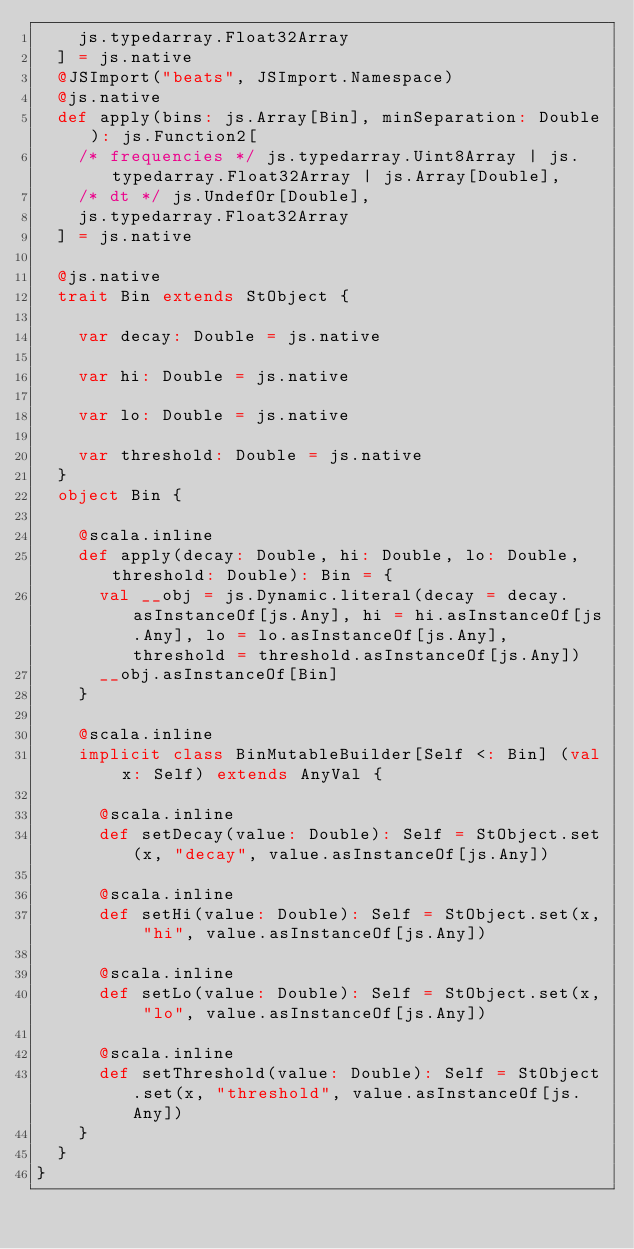<code> <loc_0><loc_0><loc_500><loc_500><_Scala_>    js.typedarray.Float32Array
  ] = js.native
  @JSImport("beats", JSImport.Namespace)
  @js.native
  def apply(bins: js.Array[Bin], minSeparation: Double): js.Function2[
    /* frequencies */ js.typedarray.Uint8Array | js.typedarray.Float32Array | js.Array[Double], 
    /* dt */ js.UndefOr[Double], 
    js.typedarray.Float32Array
  ] = js.native
  
  @js.native
  trait Bin extends StObject {
    
    var decay: Double = js.native
    
    var hi: Double = js.native
    
    var lo: Double = js.native
    
    var threshold: Double = js.native
  }
  object Bin {
    
    @scala.inline
    def apply(decay: Double, hi: Double, lo: Double, threshold: Double): Bin = {
      val __obj = js.Dynamic.literal(decay = decay.asInstanceOf[js.Any], hi = hi.asInstanceOf[js.Any], lo = lo.asInstanceOf[js.Any], threshold = threshold.asInstanceOf[js.Any])
      __obj.asInstanceOf[Bin]
    }
    
    @scala.inline
    implicit class BinMutableBuilder[Self <: Bin] (val x: Self) extends AnyVal {
      
      @scala.inline
      def setDecay(value: Double): Self = StObject.set(x, "decay", value.asInstanceOf[js.Any])
      
      @scala.inline
      def setHi(value: Double): Self = StObject.set(x, "hi", value.asInstanceOf[js.Any])
      
      @scala.inline
      def setLo(value: Double): Self = StObject.set(x, "lo", value.asInstanceOf[js.Any])
      
      @scala.inline
      def setThreshold(value: Double): Self = StObject.set(x, "threshold", value.asInstanceOf[js.Any])
    }
  }
}
</code> 